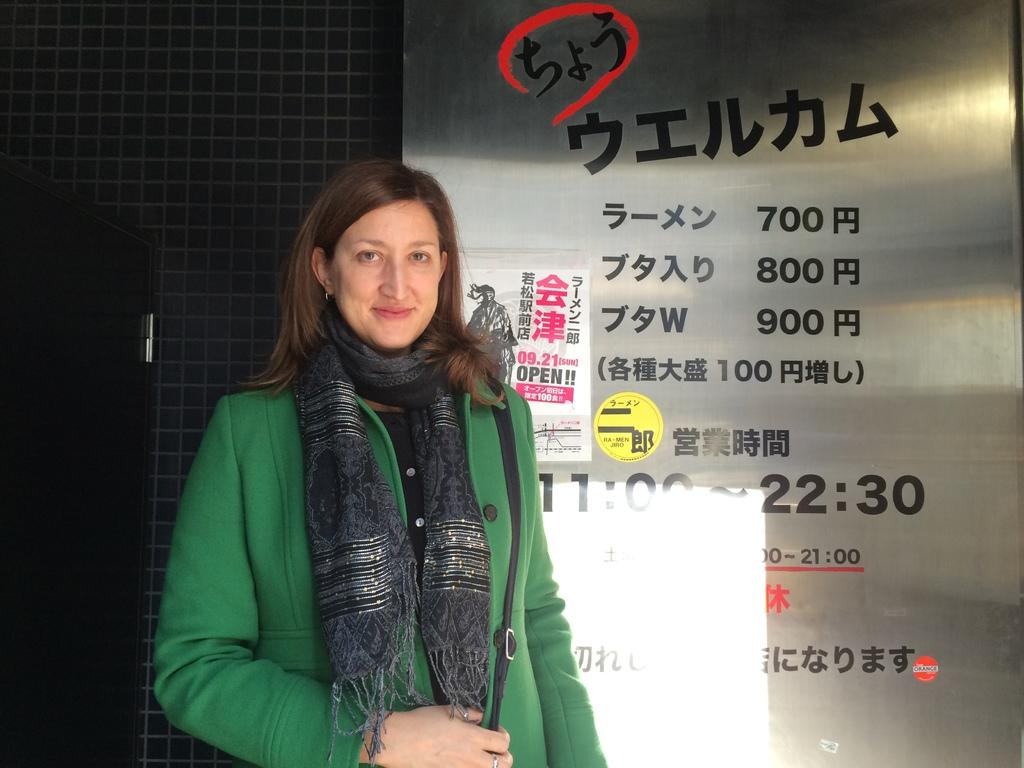Who is present in the image? There is a woman in the image. What is the woman doing in the image? The woman is standing. What is the woman wearing in the image? The woman is wearing a coat and a scarf. What is the woman carrying in the image? The woman is carrying a bag. What can be seen in the background of the image? There is a wall, a banner, and a door in the background of the image. Can you see the ocean in the background of the image? No, the ocean is not present in the background of the image. Is the woman folding her coat in the image? No, the woman is not folding her coat in the image; she is wearing it. 